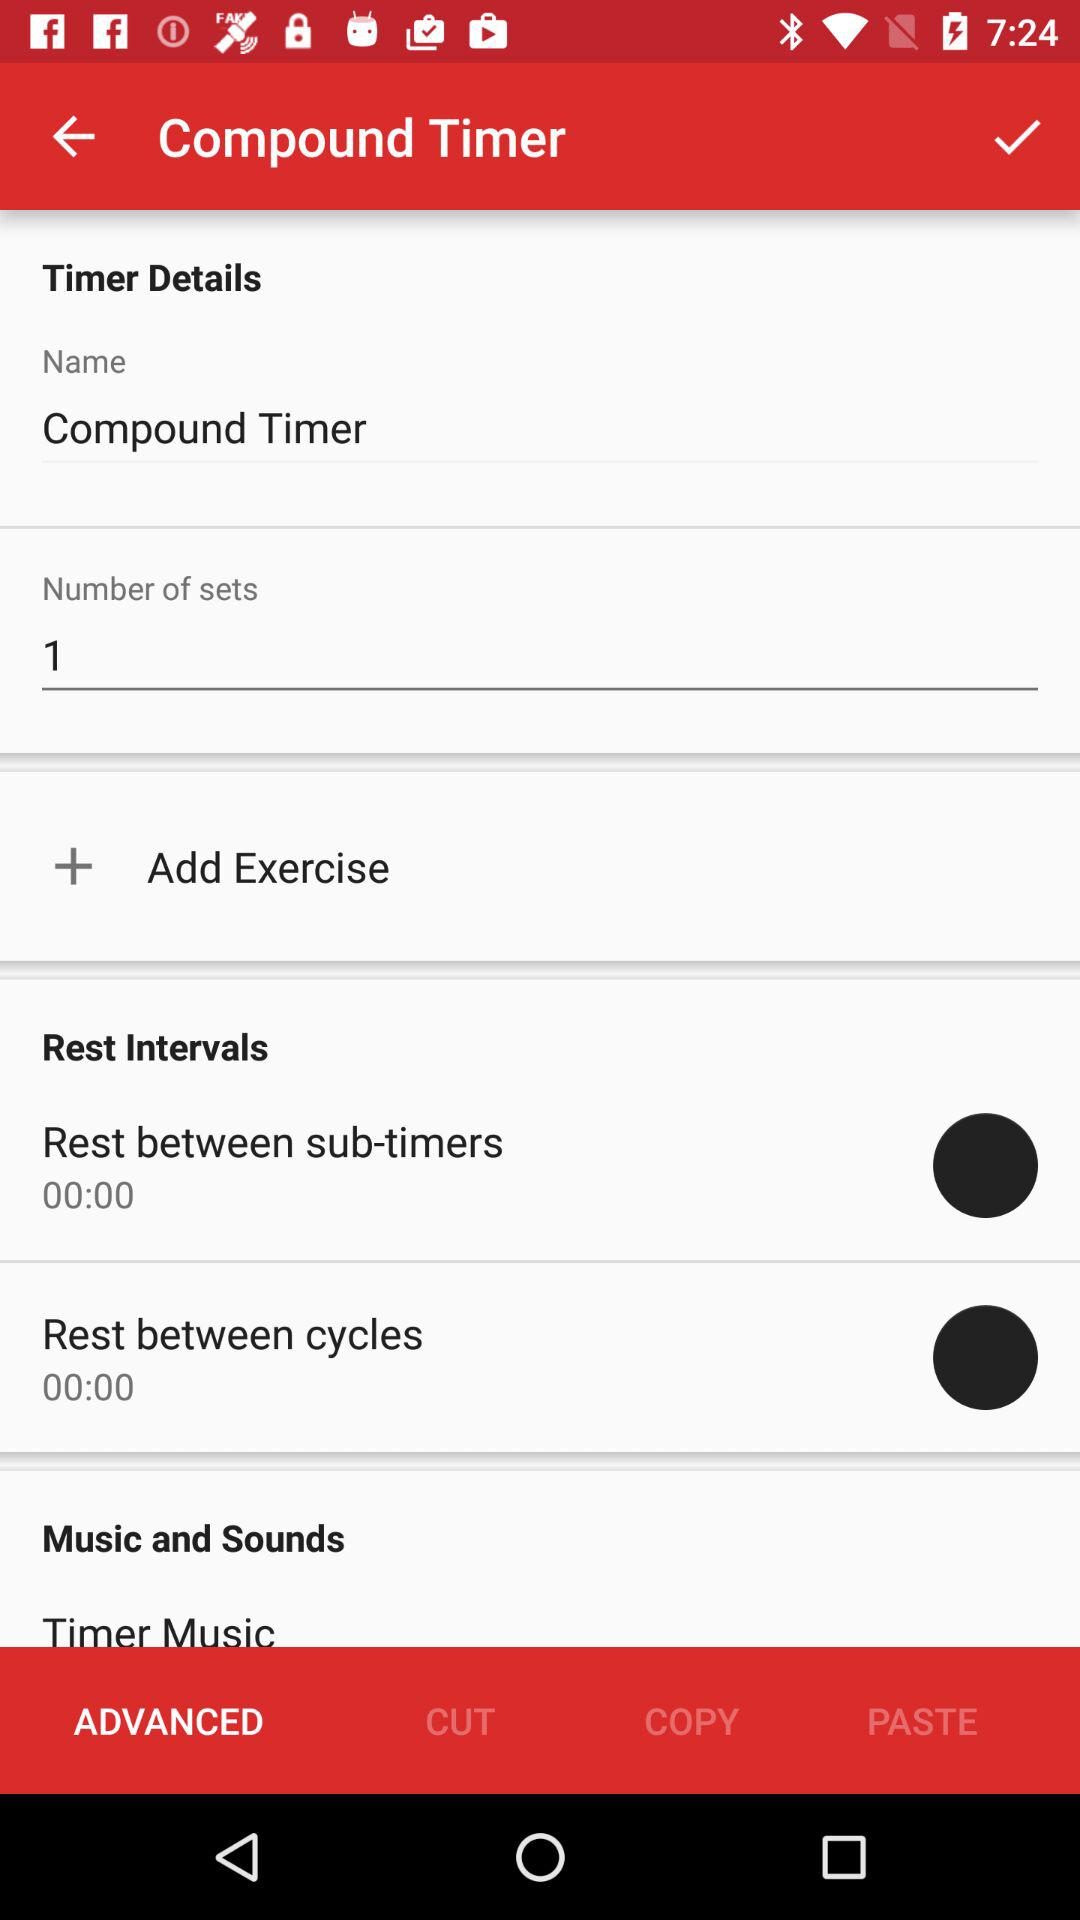How many seconds of rest are there between each sub-timer?
Answer the question using a single word or phrase. 00:00 